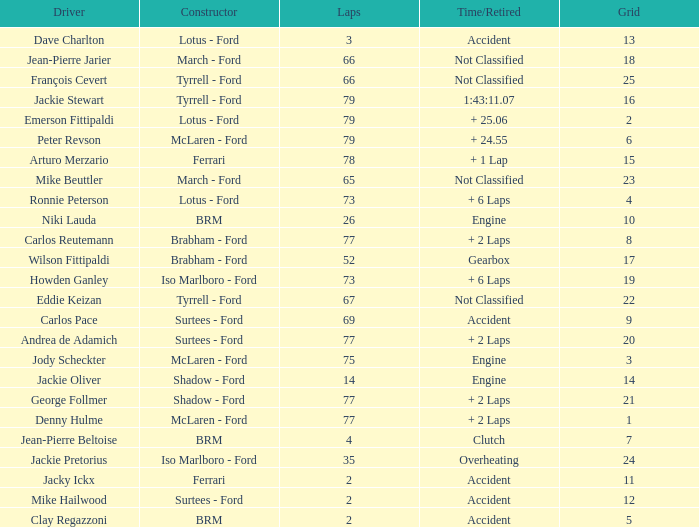How much time is required for less than 35 laps and less than 10 grids? Clutch, Accident. 